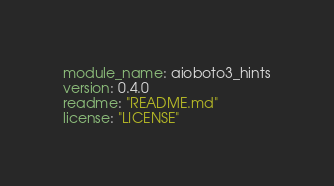Convert code to text. <code><loc_0><loc_0><loc_500><loc_500><_YAML_>module_name: aioboto3_hints
version: 0.4.0
readme: "README.md"
license: "LICENSE"</code> 